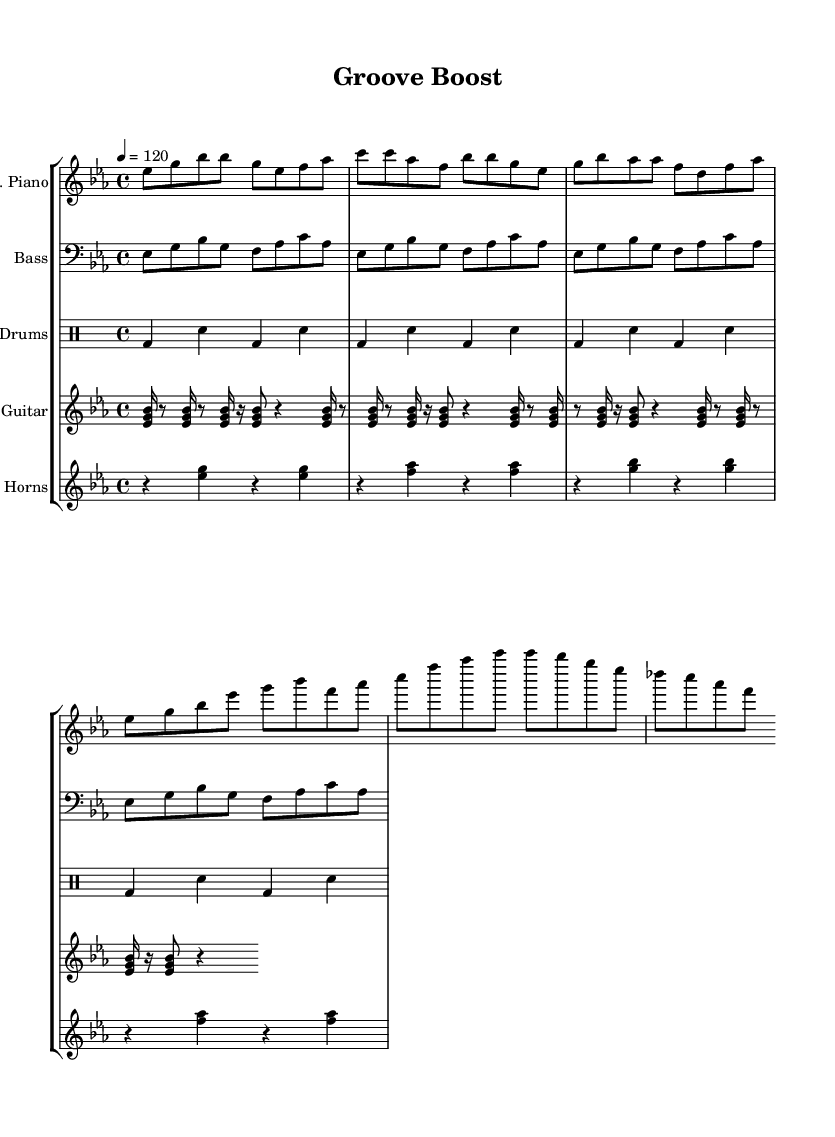What is the key signature of this music? The key signature is indicated by the presence of three flats in the music (B flat, E flat, and A flat) on the staff. This corresponds to the key of E flat major.
Answer: E flat major What is the time signature of the sheet music? The time signature is located at the beginning of the piece, represented as a fraction. It shows that there are four beats in a measure and the quarter note gets one beat, confirming the 4/4 time signature.
Answer: 4/4 What is the tempo marking of the piece? The tempo marking is given at the beginning of the score, stating that the piece should be played at a speed of 120 beats per minute. This is shown with "4 = 120".
Answer: 120 How many measures are in the bass line section? To determine this, we need to count the measures in the bass line notation. The bass line is structured to repeat four times and each group contains one measure. Thus, the total is four measures.
Answer: 4 What kind of instrumental sections are present in the score? By looking at the score layout, we can see multiple staves indicating different instruments, including an electric piano, bass guitar, drums, rhythm guitar, and horns. This indicates a collaborative instrumental section typical of funk-soul.
Answer: Electric piano, bass guitar, drums, rhythm guitar, horns What is the significance of the rhythm used in the guitar section? The rhythm in the guitar section employs sixteenth notes followed by rests, creating a syncopated funky feel. This plays a crucial role in maintaining the upbeat and dynamic energy characteristic of funk-soul music.
Answer: Syncopated funky feel Which instruments play a repetitive pattern in this piece? The bass guitar plays a repeating pattern as indicated by the "repeat unfold" command in the bass line section, demonstrating the groove essential for funk-soul.
Answer: Bass guitar 